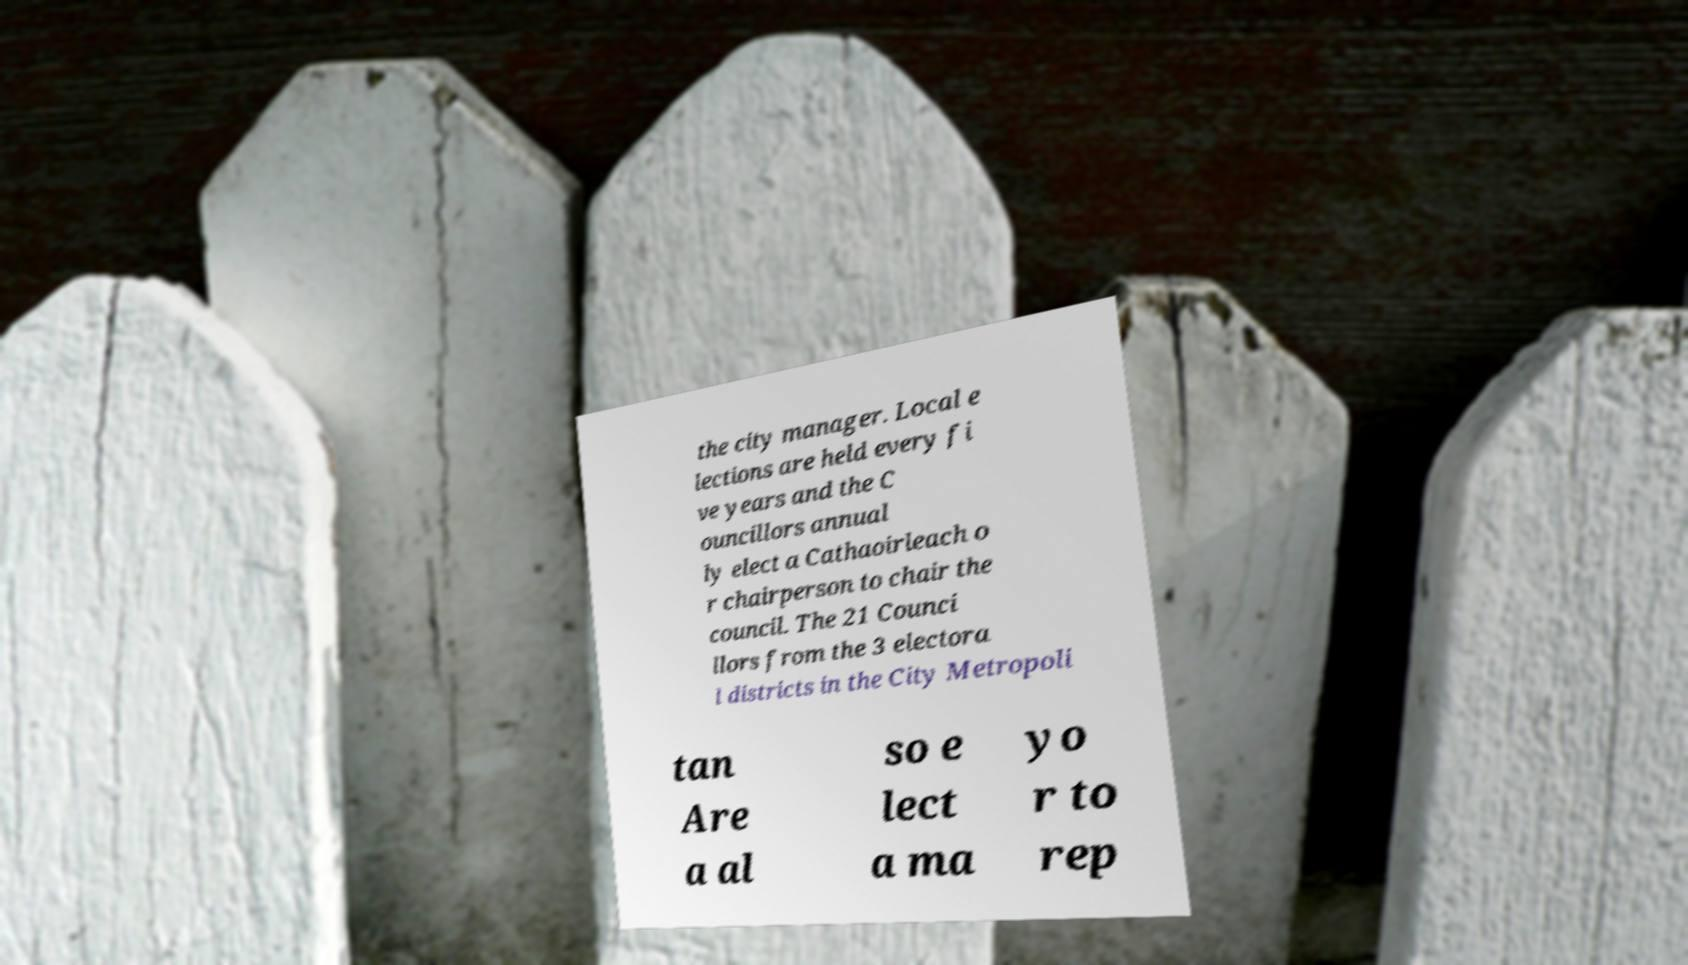What messages or text are displayed in this image? I need them in a readable, typed format. the city manager. Local e lections are held every fi ve years and the C ouncillors annual ly elect a Cathaoirleach o r chairperson to chair the council. The 21 Counci llors from the 3 electora l districts in the City Metropoli tan Are a al so e lect a ma yo r to rep 